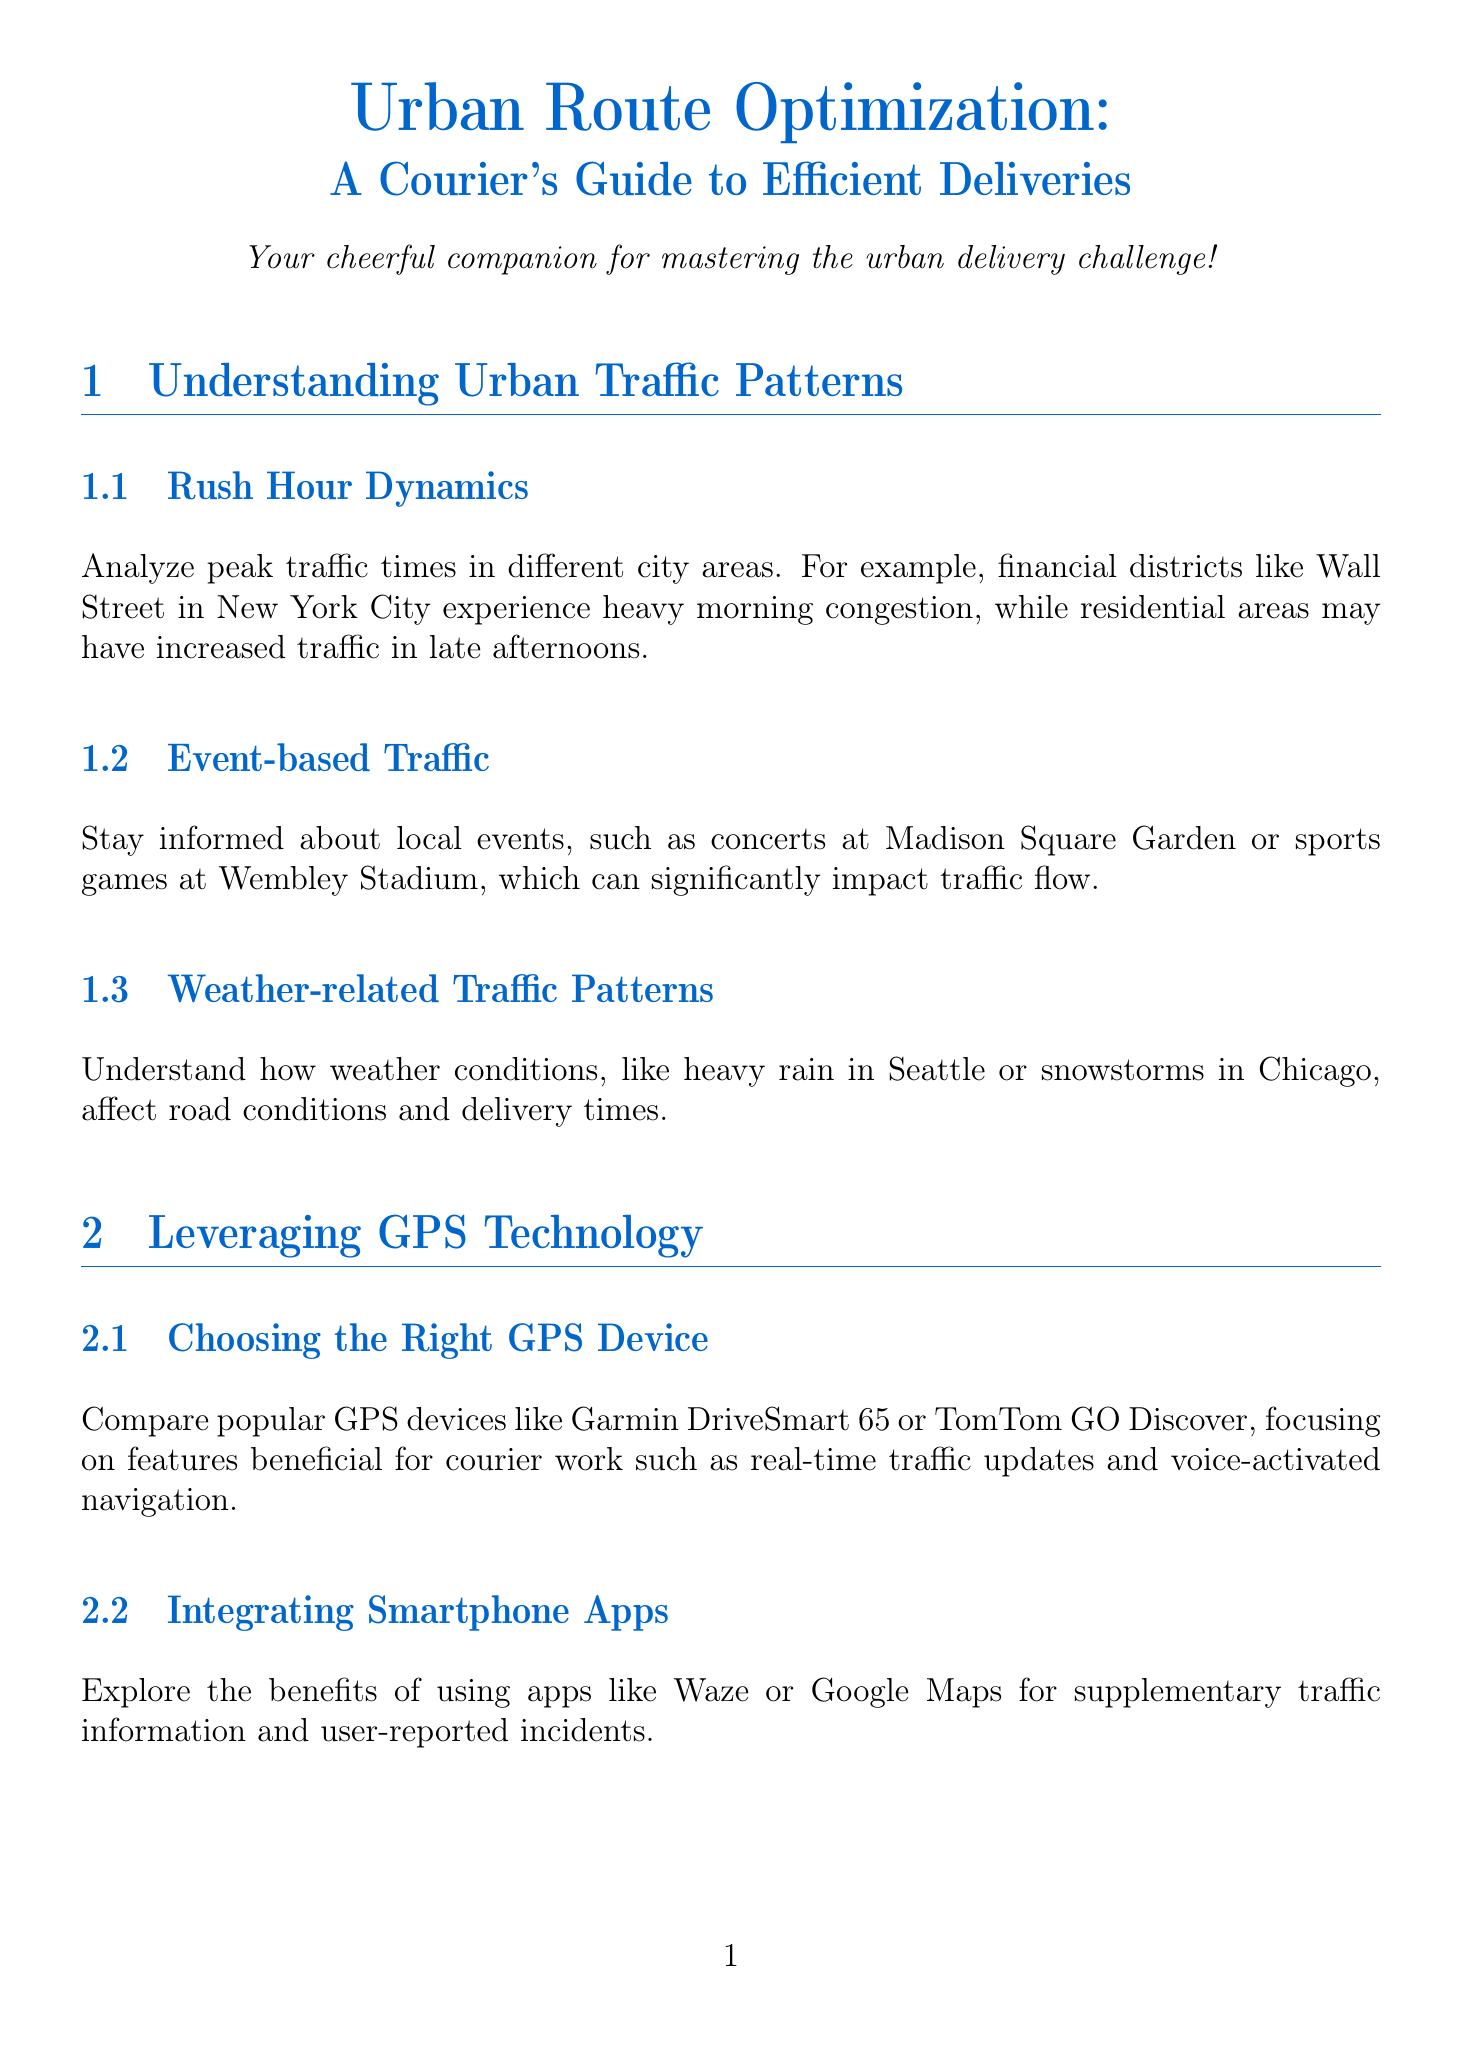What are the three factors that affect urban traffic patterns? The document outlines Rush Hour Dynamics, Event-based Traffic, and Weather-related Traffic Patterns as key factors affecting urban traffic.
Answer: Rush Hour Dynamics, Event-based Traffic, Weather-related Traffic Patterns Which GPS devices are mentioned for courier work? Popular GPS devices mentioned in the document include Garmin DriveSmart 65 and TomTom GO Discover.
Answer: Garmin DriveSmart 65, TomTom GO Discover What optimization software is recommended for multi-stop route planning? The document suggests using RouteXL or Routific for efficiently planning deliveries with multiple stops.
Answer: RouteXL, Routific How can a courier navigate unexpected road closures? The document advises developing strategies for quick decision-making using alternative routes in grid-based cities.
Answer: Using alternative routes What loading technique is suggested for package organization? Efficient loading techniques include the LIFO (Last-In-First-Out) method for easy access to packages.
Answer: LIFO What does the conclusion encourage couriers to focus on? The conclusion emphasizes viewing each delivery as an opportunity to optimize routes and cheer up customers, celebrating timely deliveries.
Answer: Optimizing routes and cheering up customers 